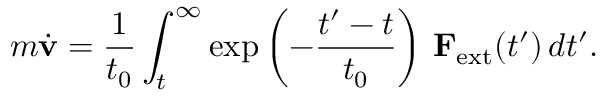<formula> <loc_0><loc_0><loc_500><loc_500>m { \dot { v } } = { \frac { 1 } { t _ { 0 } } } \int _ { t } ^ { \infty } \exp \left ( - { \frac { t ^ { \prime } - t } { t _ { 0 } } } \right ) \, F _ { e x t } ( t ^ { \prime } ) \, d t ^ { \prime } .</formula> 